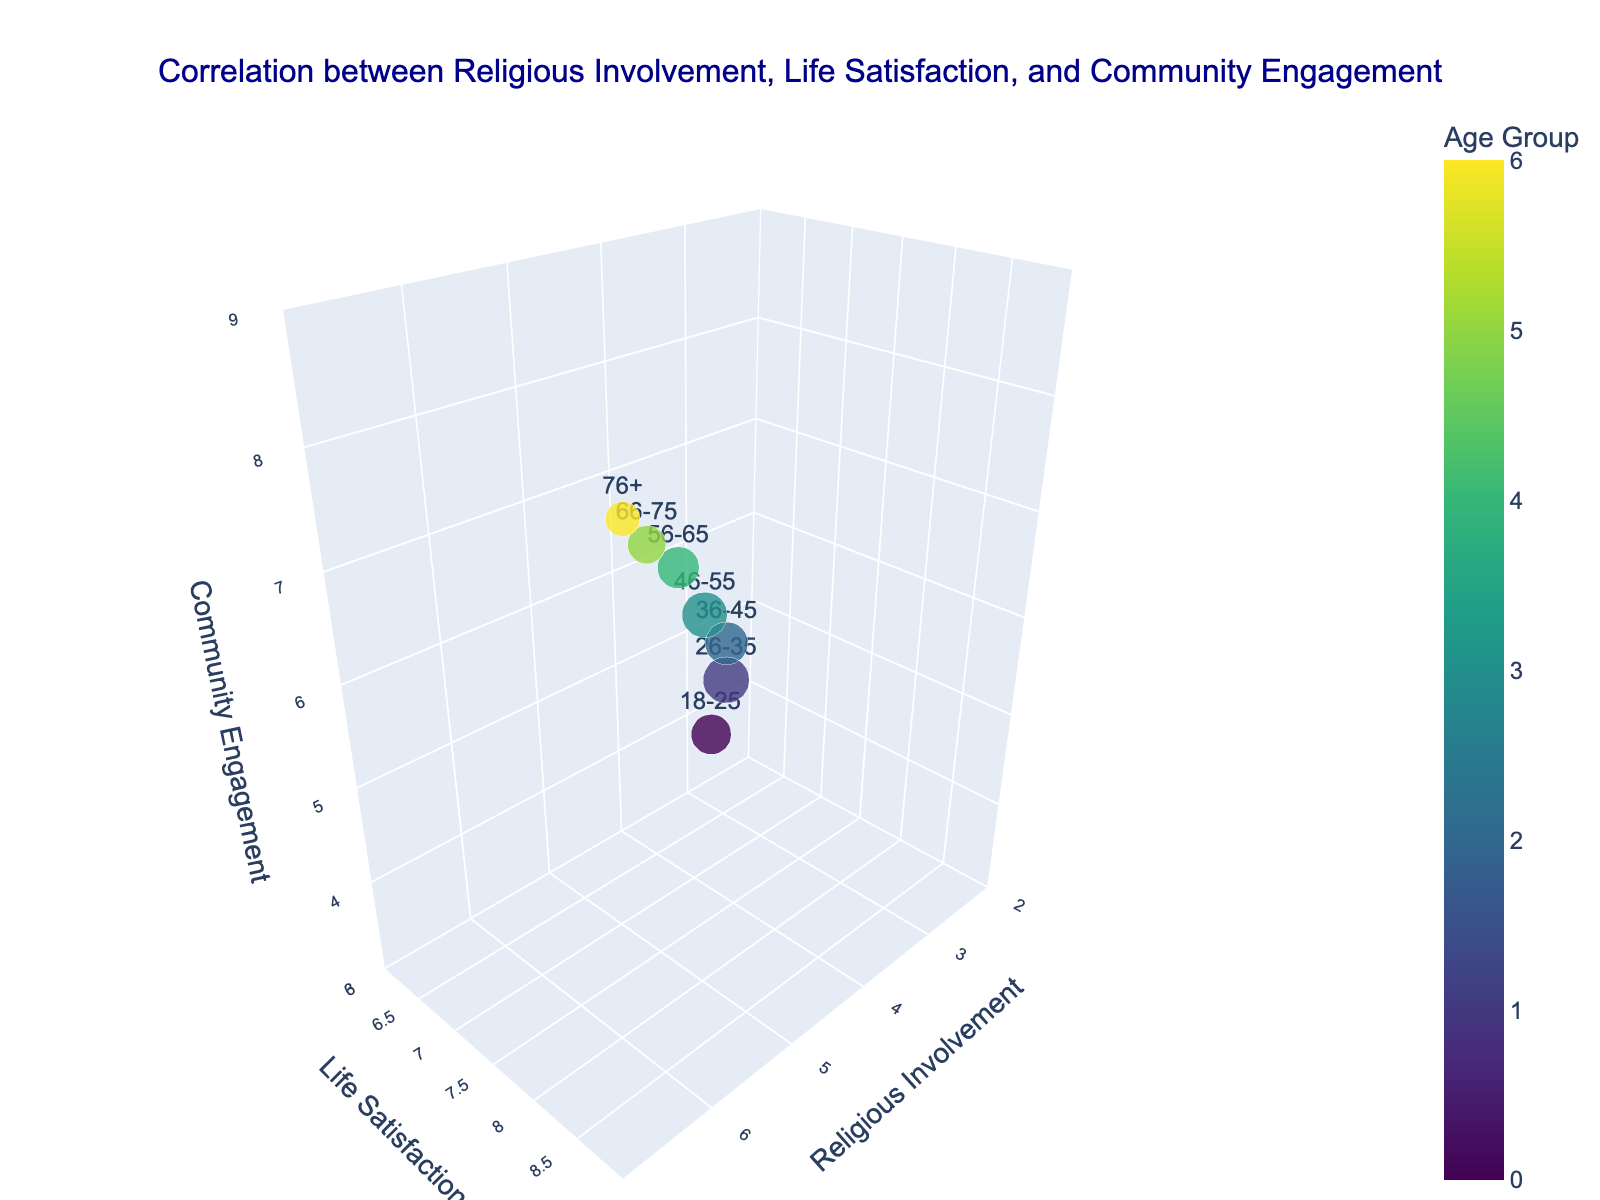What is the title of the figure? The title is typically displayed at the top of the figure. In this case, it reads "Correlation between Religious Involvement, Life Satisfaction, and Community Engagement."
Answer: Correlation between Religious Involvement, Life Satisfaction, and Community Engagement What does the size of the bubbles represent? The figure includes a marker size, which is often used to indicate a numeric value. According to the provided code, the size of the bubbles represents the Sample Size. This is mentioned in the marker dictionary where `size` is `Sample Size / 20`.
Answer: Sample Size What axis represents Life Satisfaction? Typically, axis titles are marked clearly in the figure. Here, the y-axis is labeled 'Life Satisfaction'. This can be confirmed by referring to the scene dictionary in the code where the y-axis title is set as 'Life Satisfaction'.
Answer: y-axis Which age group has the highest community engagement? Observing the z-axis titled "Community Engagement", we look for the highest value. The "76+" age group has the highest community engagement value of 8.2 as noted in the data.
Answer: 76+ What are the ranges of values on the x-axis, y-axis, and z-axis? By looking at the axis titles and values, we can infer the range of each axis. From the code: x-axis (Religious Involvement) ranges from 2 to 7, y-axis (Life Satisfaction) ranges from 6 to 9, and z-axis (Community Engagement) ranges from 3 to 9. These ranges are set in the scene dictionary.
Answer: x: 2-7, y: 6-9, z: 3-9 Which age group has the largest bubble size and what does it represent? Bubble size represents Sample Size. By looking at the figure, the largest bubble can be identified as the one corresponding to the largest sample size, which is 520. This belongs to the age group '26-35'.
Answer: 26-35, Sample Size How does life satisfaction change as religious involvement increases? Observing the trend along the axes, as religious involvement (x-axis) increases, life satisfaction (y-axis) also generally increases from 6.5 to 8.7. This indicates a positive correlation.
Answer: Increases Compare the life satisfaction and community engagement of the 18-25 and 66-75 age groups. From the hover text or bubble positions: the 18-25 age group has a life satisfaction of 6.5 and community engagement of 4.1, whereas the 66-75 age group has a life satisfaction of 8.6 and community engagement of 7.9. Thus, the latter shows higher values in both metrics.
Answer: 66-75 has higher values Calculate the average life satisfaction across all age groups. Average can be calculated by summing the life satisfaction values and dividing by the number of groups: (6.5 + 7.2 + 7.8 + 8.1 + 8.4 + 8.6 + 8.7) / 7 = 55.3 / 7 ≈ 7.9
Answer: 7.9 Between which two age groups is there the largest increase in Community Engagement? Observing the z-axis values incrementally: the largest increase occurs between '26-35' (5.3) and '36-45' (6.2). The increase is 0.9.
Answer: 26-35 and 36-45 